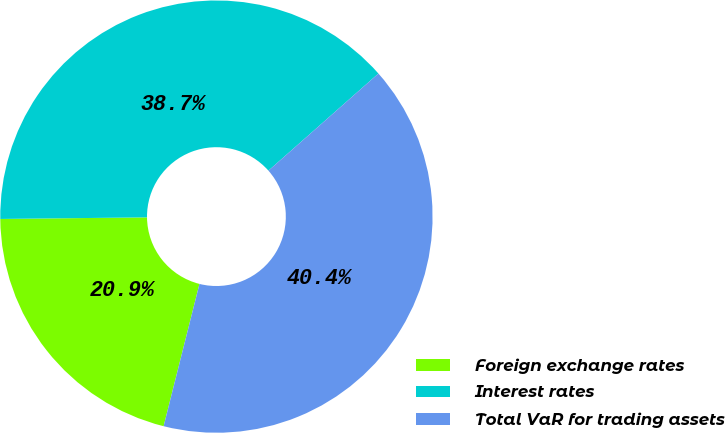Convert chart to OTSL. <chart><loc_0><loc_0><loc_500><loc_500><pie_chart><fcel>Foreign exchange rates<fcel>Interest rates<fcel>Total VaR for trading assets<nl><fcel>20.9%<fcel>38.66%<fcel>40.44%<nl></chart> 